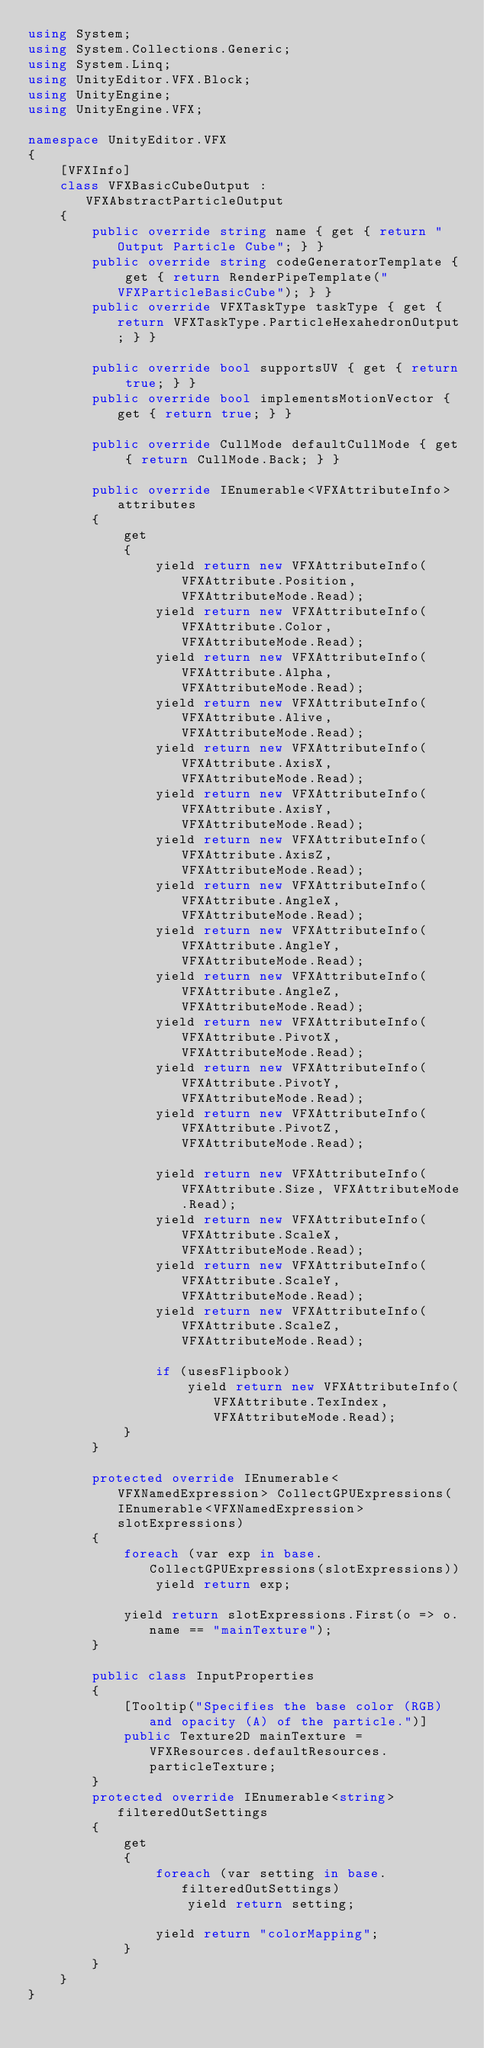<code> <loc_0><loc_0><loc_500><loc_500><_C#_>using System;
using System.Collections.Generic;
using System.Linq;
using UnityEditor.VFX.Block;
using UnityEngine;
using UnityEngine.VFX;

namespace UnityEditor.VFX
{
    [VFXInfo]
    class VFXBasicCubeOutput : VFXAbstractParticleOutput
    {
        public override string name { get { return "Output Particle Cube"; } }
        public override string codeGeneratorTemplate { get { return RenderPipeTemplate("VFXParticleBasicCube"); } }
        public override VFXTaskType taskType { get { return VFXTaskType.ParticleHexahedronOutput; } }

        public override bool supportsUV { get { return true; } }
        public override bool implementsMotionVector { get { return true; } }

        public override CullMode defaultCullMode { get { return CullMode.Back; } }

        public override IEnumerable<VFXAttributeInfo> attributes
        {
            get
            {
                yield return new VFXAttributeInfo(VFXAttribute.Position, VFXAttributeMode.Read);
                yield return new VFXAttributeInfo(VFXAttribute.Color, VFXAttributeMode.Read);
                yield return new VFXAttributeInfo(VFXAttribute.Alpha, VFXAttributeMode.Read);
                yield return new VFXAttributeInfo(VFXAttribute.Alive, VFXAttributeMode.Read);
                yield return new VFXAttributeInfo(VFXAttribute.AxisX, VFXAttributeMode.Read);
                yield return new VFXAttributeInfo(VFXAttribute.AxisY, VFXAttributeMode.Read);
                yield return new VFXAttributeInfo(VFXAttribute.AxisZ, VFXAttributeMode.Read);
                yield return new VFXAttributeInfo(VFXAttribute.AngleX, VFXAttributeMode.Read);
                yield return new VFXAttributeInfo(VFXAttribute.AngleY, VFXAttributeMode.Read);
                yield return new VFXAttributeInfo(VFXAttribute.AngleZ, VFXAttributeMode.Read);
                yield return new VFXAttributeInfo(VFXAttribute.PivotX, VFXAttributeMode.Read);
                yield return new VFXAttributeInfo(VFXAttribute.PivotY, VFXAttributeMode.Read);
                yield return new VFXAttributeInfo(VFXAttribute.PivotZ, VFXAttributeMode.Read);

                yield return new VFXAttributeInfo(VFXAttribute.Size, VFXAttributeMode.Read);
                yield return new VFXAttributeInfo(VFXAttribute.ScaleX, VFXAttributeMode.Read);
                yield return new VFXAttributeInfo(VFXAttribute.ScaleY, VFXAttributeMode.Read);
                yield return new VFXAttributeInfo(VFXAttribute.ScaleZ, VFXAttributeMode.Read);

                if (usesFlipbook)
                    yield return new VFXAttributeInfo(VFXAttribute.TexIndex, VFXAttributeMode.Read);
            }
        }

        protected override IEnumerable<VFXNamedExpression> CollectGPUExpressions(IEnumerable<VFXNamedExpression> slotExpressions)
        {
            foreach (var exp in base.CollectGPUExpressions(slotExpressions))
                yield return exp;

            yield return slotExpressions.First(o => o.name == "mainTexture");
        }

        public class InputProperties
        {
            [Tooltip("Specifies the base color (RGB) and opacity (A) of the particle.")]
            public Texture2D mainTexture = VFXResources.defaultResources.particleTexture;
        }
        protected override IEnumerable<string> filteredOutSettings
        {
            get
            {
                foreach (var setting in base.filteredOutSettings)
                    yield return setting;

                yield return "colorMapping";
            }
        }
    }
}
</code> 